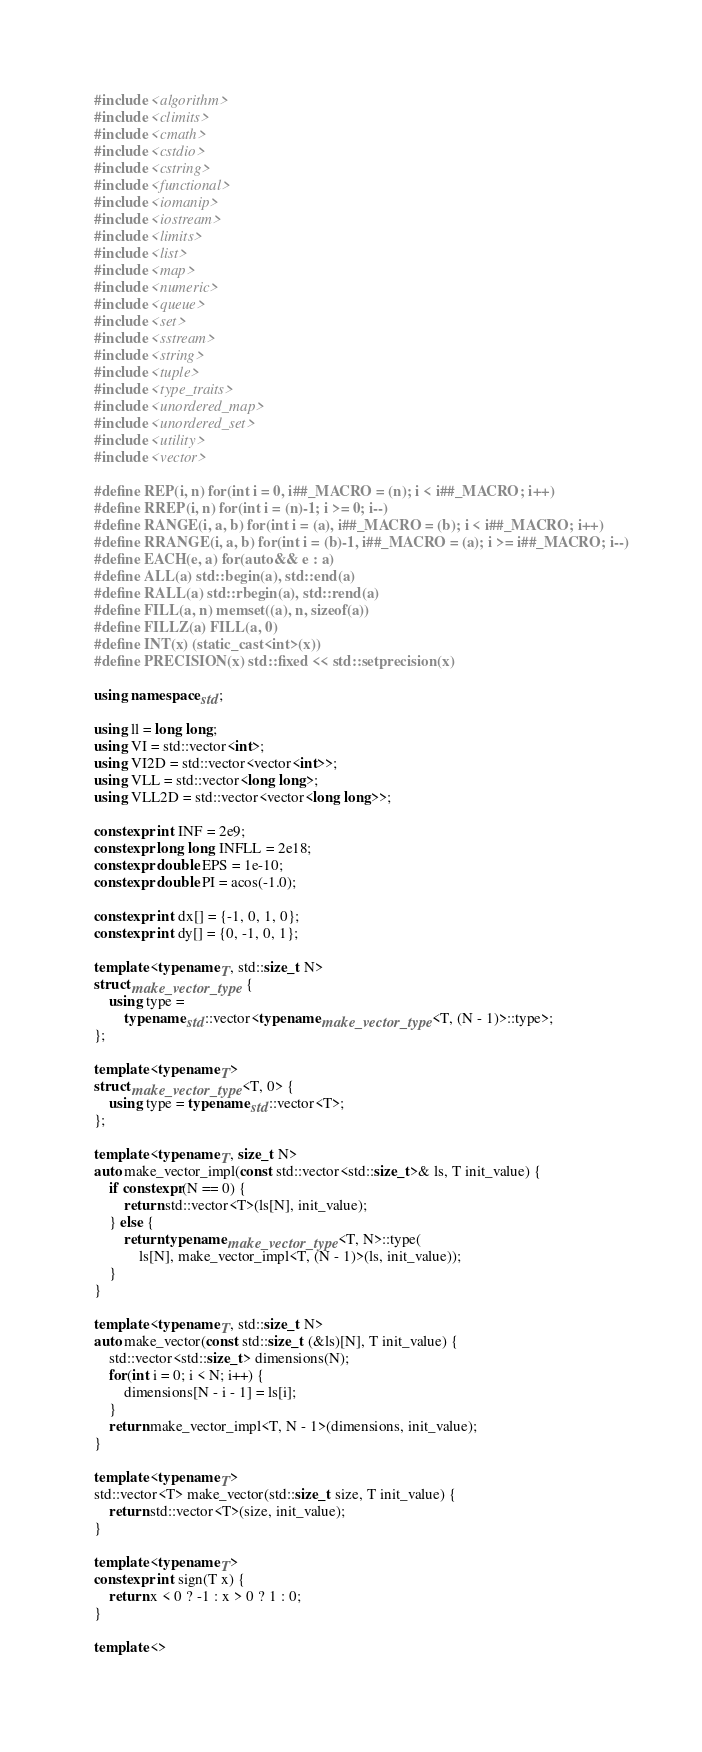<code> <loc_0><loc_0><loc_500><loc_500><_C++_>#include <algorithm>
#include <climits>
#include <cmath>
#include <cstdio>
#include <cstring>
#include <functional>
#include <iomanip>
#include <iostream>
#include <limits>
#include <list>
#include <map>
#include <numeric>
#include <queue>
#include <set>
#include <sstream>
#include <string>
#include <tuple>
#include <type_traits>
#include <unordered_map>
#include <unordered_set>
#include <utility>
#include <vector>

#define REP(i, n) for(int i = 0, i##_MACRO = (n); i < i##_MACRO; i++)
#define RREP(i, n) for(int i = (n)-1; i >= 0; i--)
#define RANGE(i, a, b) for(int i = (a), i##_MACRO = (b); i < i##_MACRO; i++)
#define RRANGE(i, a, b) for(int i = (b)-1, i##_MACRO = (a); i >= i##_MACRO; i--)
#define EACH(e, a) for(auto&& e : a)
#define ALL(a) std::begin(a), std::end(a)
#define RALL(a) std::rbegin(a), std::rend(a)
#define FILL(a, n) memset((a), n, sizeof(a))
#define FILLZ(a) FILL(a, 0)
#define INT(x) (static_cast<int>(x))
#define PRECISION(x) std::fixed << std::setprecision(x)

using namespace std;

using ll = long long;
using VI = std::vector<int>;
using VI2D = std::vector<vector<int>>;
using VLL = std::vector<long long>;
using VLL2D = std::vector<vector<long long>>;

constexpr int INF = 2e9;
constexpr long long INFLL = 2e18;
constexpr double EPS = 1e-10;
constexpr double PI = acos(-1.0);

constexpr int dx[] = {-1, 0, 1, 0};
constexpr int dy[] = {0, -1, 0, 1};

template <typename T, std::size_t N>
struct make_vector_type {
	using type =
		typename std::vector<typename make_vector_type<T, (N - 1)>::type>;
};

template <typename T>
struct make_vector_type<T, 0> {
	using type = typename std::vector<T>;
};

template <typename T, size_t N>
auto make_vector_impl(const std::vector<std::size_t>& ls, T init_value) {
	if constexpr(N == 0) {
		return std::vector<T>(ls[N], init_value);
	} else {
		return typename make_vector_type<T, N>::type(
			ls[N], make_vector_impl<T, (N - 1)>(ls, init_value));
	}
}

template <typename T, std::size_t N>
auto make_vector(const std::size_t (&ls)[N], T init_value) {
	std::vector<std::size_t> dimensions(N);
	for(int i = 0; i < N; i++) {
		dimensions[N - i - 1] = ls[i];
	}
	return make_vector_impl<T, N - 1>(dimensions, init_value);
}

template <typename T>
std::vector<T> make_vector(std::size_t size, T init_value) {
	return std::vector<T>(size, init_value);
}

template <typename T>
constexpr int sign(T x) {
	return x < 0 ? -1 : x > 0 ? 1 : 0;
}

template <></code> 